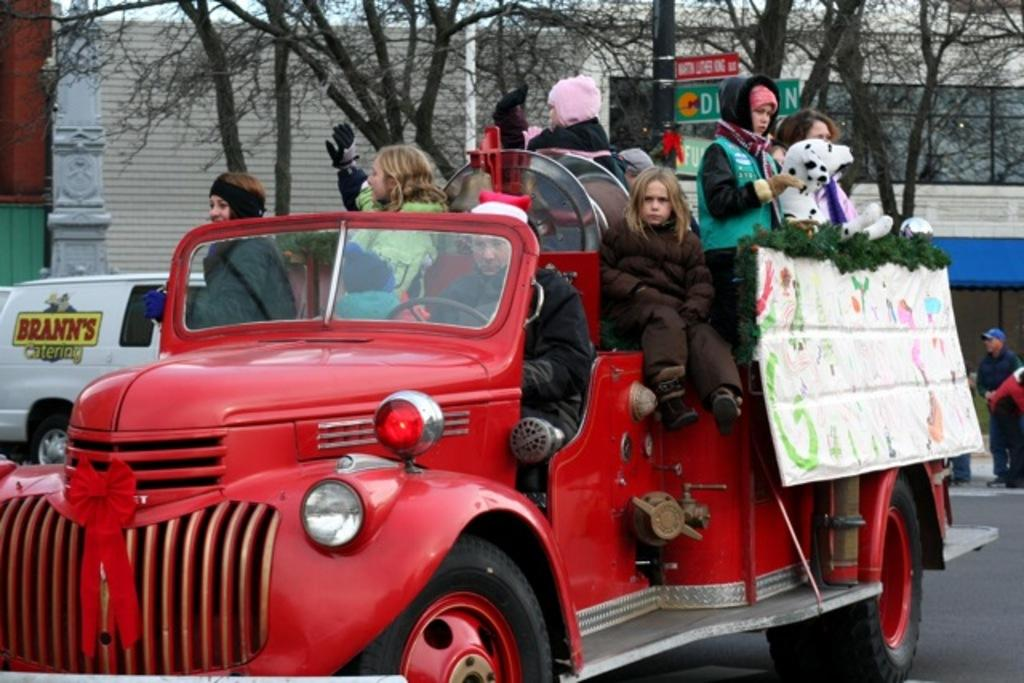What color is the vehicle in the image? The vehicle in the image is red. Who or what is on the vehicle? People are present on the vehicle. What type of animal is in the image? There is a white dog in the image. What object can be seen in the image? There is a board in the image. What can be seen in the background of the image? Trees, sign boards, and buildings are visible in the background of the image. How many tickets are attached to the icicle in the image? There is no icicle present in the image, and therefore no tickets can be attached to it. What verse is written on the board in the image? There is no verse written on the board in the image; it is just a plain board. 